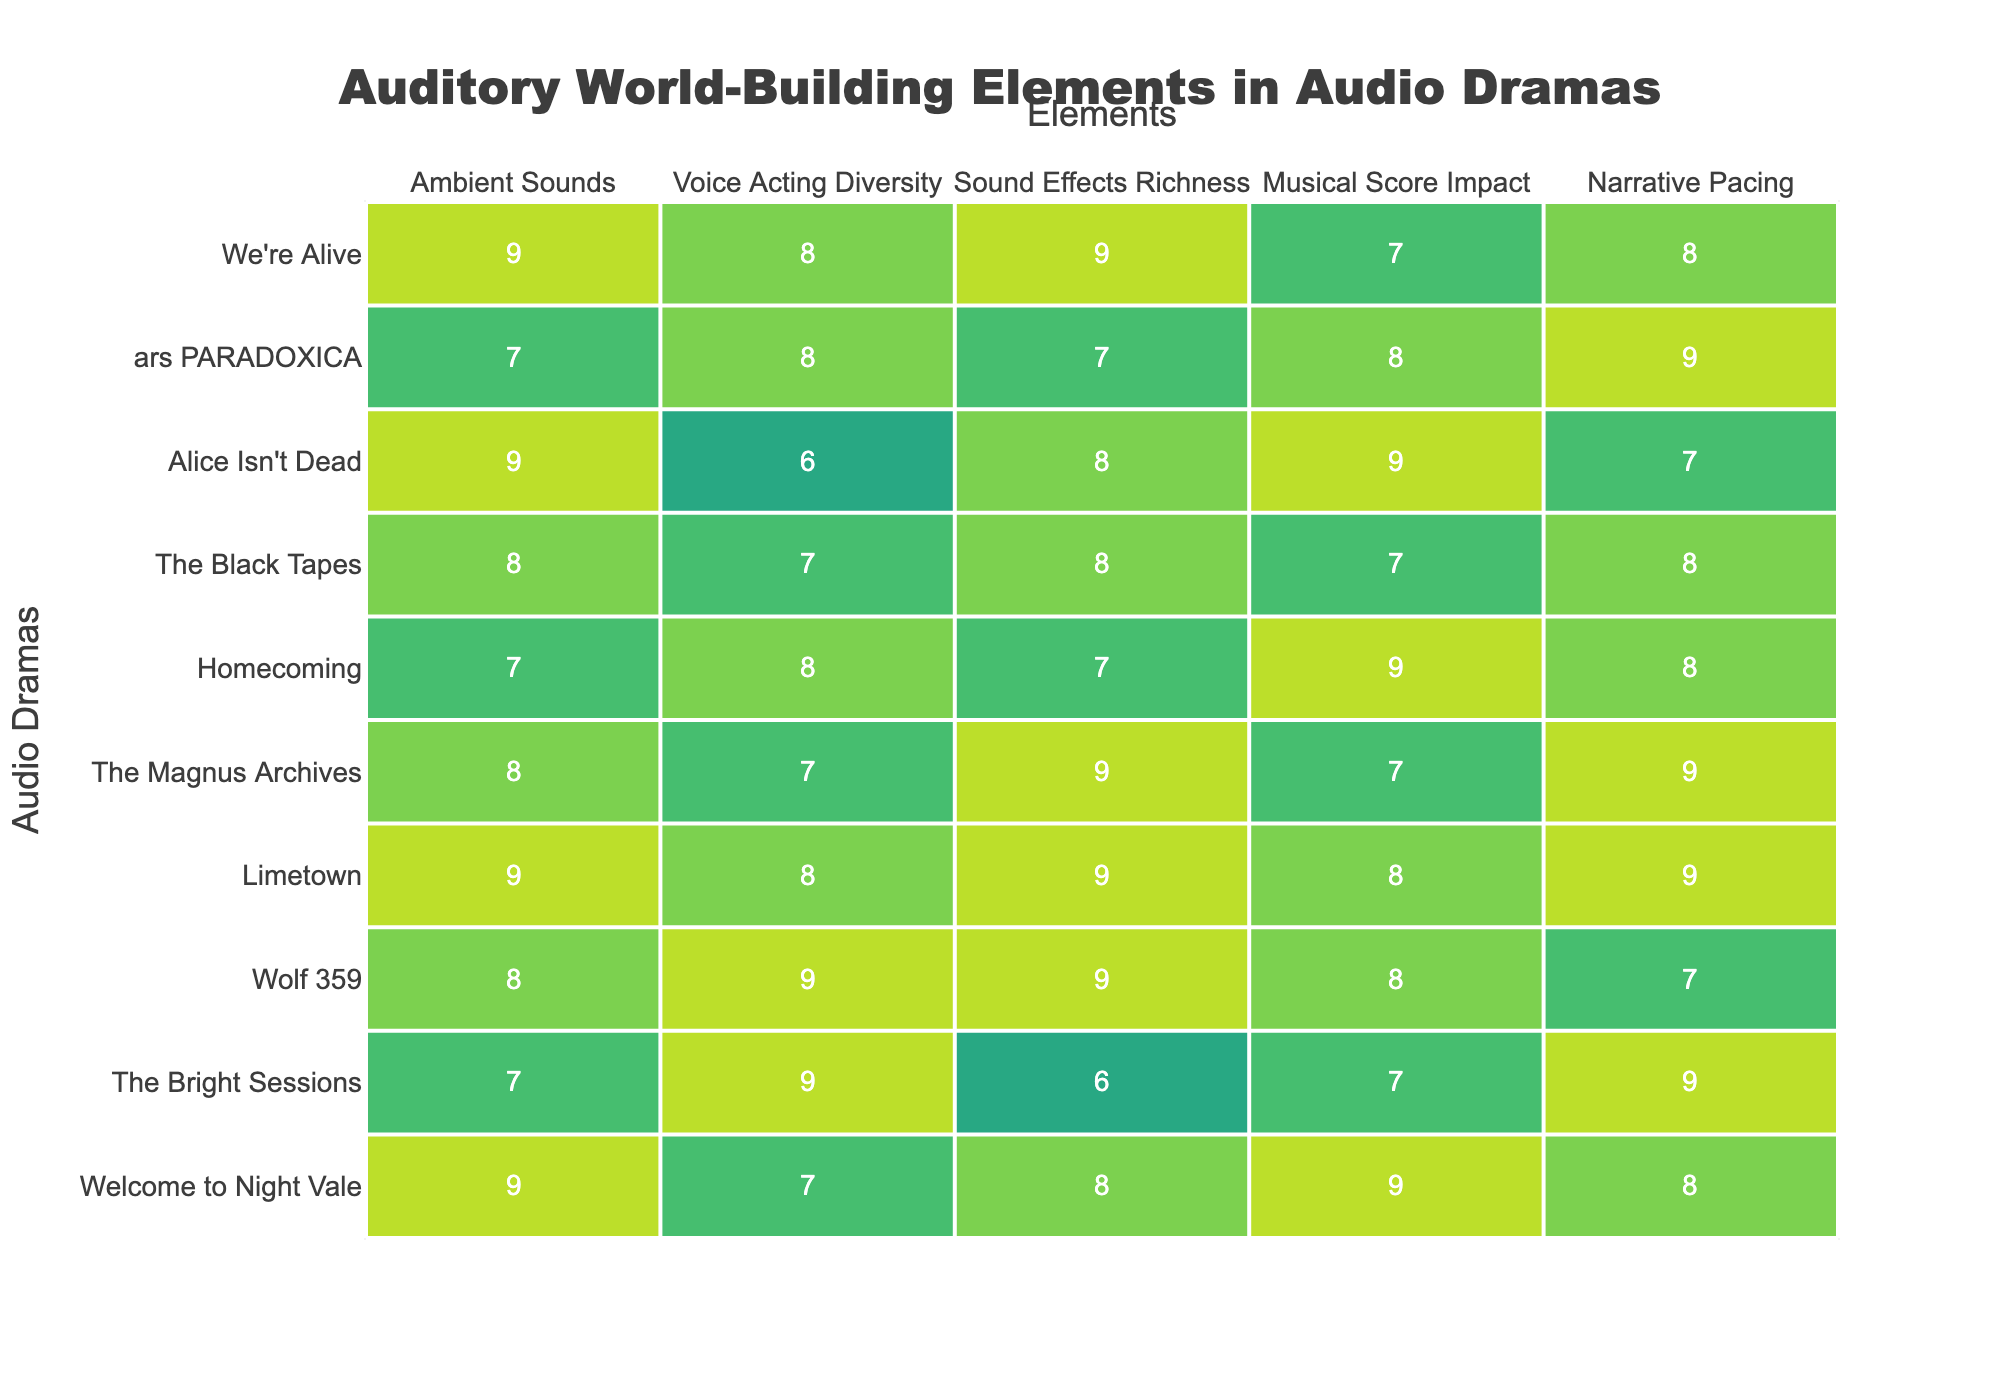What is the highest rating for Ambient Sounds among the audio dramas? The ratings for Ambient Sounds are 9 for "Welcome to Night Vale," "Limetown," and "We're Alive." Since 9 is the highest score listed, the answer is 9.
Answer: 9 Which audio drama has the lowest rating in Voice Acting Diversity? The ratings for Voice Acting Diversity show that "Alice Isn't Dead" has the lowest score of 6.
Answer: 6 What is the average rating for Sound Effects Richness across all audio dramas? Adding the ratings for Sound Effects Richness yields a total of 71. Dividing this by the number of shows (10) gives an average of 7.1.
Answer: 7.1 Which audio drama has the most balanced Narrative Pacing and Musical Score Impact ratings? "Homecoming" has ratings of 9 for Musical Score Impact and 8 for Narrative Pacing. The difference is 1. Additionally, "The Bright Sessions" has 7 for Musical Score Impact and 9 for Narrative Pacing, with a difference of 2. Therefore, "Homecoming" is more balanced.
Answer: Homecoming Is there any audio drama that scored a perfect 10 in any category? Scanning through all the categories and their scores, none of the audio dramas received a perfect score of 10 in any area.
Answer: No Which audio drama has the highest combined score in Ambient Sounds and Musical Score Impact? The combined scores for "Limetown" in Ambient Sounds (9) and Musical Score Impact (8) add up to 17, while "Welcome to Night Vale," with scores of 9 and 9, totals 18. "Welcome to Night Vale" has the highest combined score.
Answer: Welcome to Night Vale How does the Voice Acting Diversity rating of "Wolf 359" compare to that of "The Magnus Archives"? "Wolf 359" has a score of 9 while "The Magnus Archives" has a score of 7. The difference is 2, indicating "Wolf 359" exceeds "The Magnus Archives" in this category.
Answer: Wolf 359 exceeds by 2 Are there any audio dramas that have the same rating for both Ambient Sounds and Sound Effects Richness? Looking at the table, "The Bright Sessions" has 7 in Ambient Sounds and 6 in Sound Effects Richness. Meanwhile, "Alice Isn't Dead" and "Homecoming" both do not qualify. In conclusion, no audio dramas have the same rating for both categories.
Answer: No 